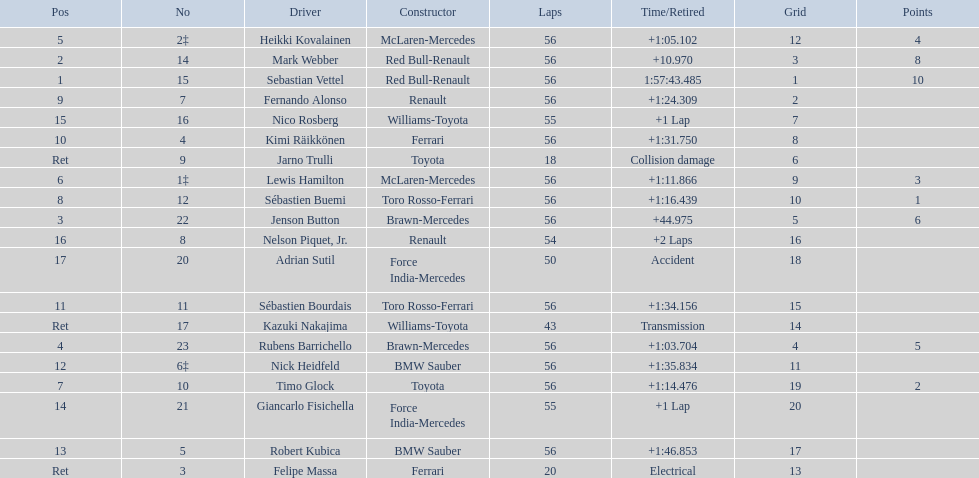Who were all of the drivers in the 2009 chinese grand prix? Sebastian Vettel, Mark Webber, Jenson Button, Rubens Barrichello, Heikki Kovalainen, Lewis Hamilton, Timo Glock, Sébastien Buemi, Fernando Alonso, Kimi Räikkönen, Sébastien Bourdais, Nick Heidfeld, Robert Kubica, Giancarlo Fisichella, Nico Rosberg, Nelson Piquet, Jr., Adrian Sutil, Kazuki Nakajima, Felipe Massa, Jarno Trulli. And what were their finishing times? 1:57:43.485, +10.970, +44.975, +1:03.704, +1:05.102, +1:11.866, +1:14.476, +1:16.439, +1:24.309, +1:31.750, +1:34.156, +1:35.834, +1:46.853, +1 Lap, +1 Lap, +2 Laps, Accident, Transmission, Electrical, Collision damage. Which player faced collision damage and retired from the race? Jarno Trulli. 